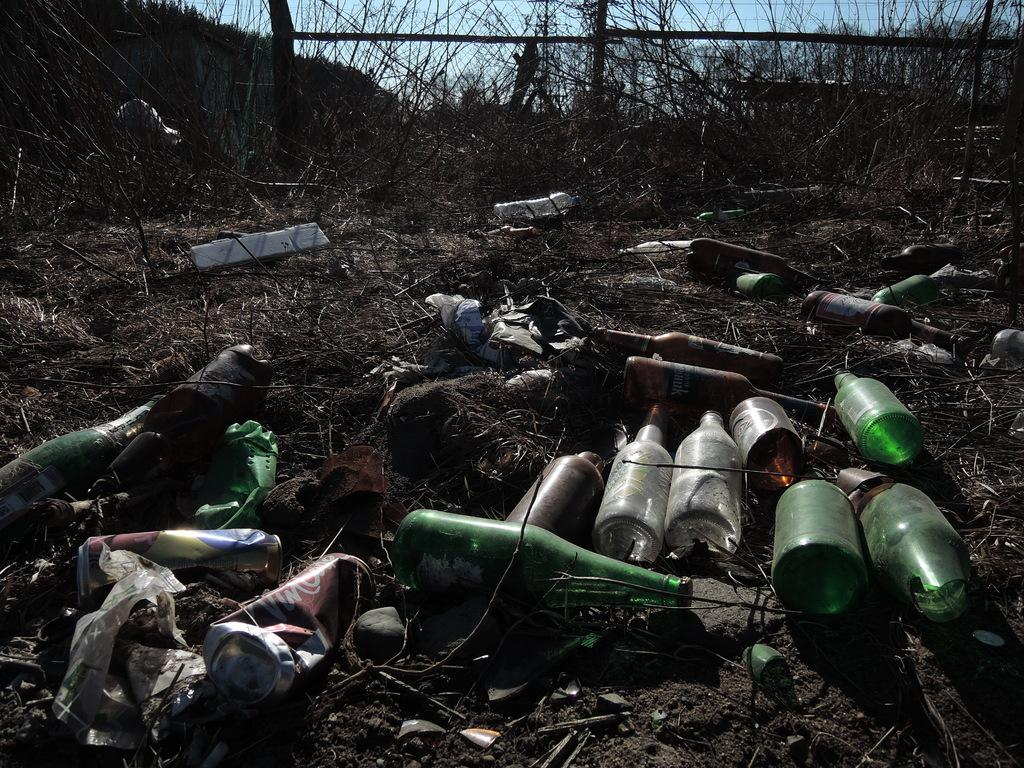What types of containers are visible in the image? There are bottles and tins in the image. What else can be seen on the ground in the image? There are other objects on the ground in the image. What is visible in the background of the image? There are trees, a fence, and the sky visible in the background of the image. What type of sweater is being worn by the tree in the background? There are no people or trees wearing sweaters in the image; the trees are natural vegetation. 